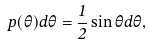Convert formula to latex. <formula><loc_0><loc_0><loc_500><loc_500>p ( \theta ) d \theta = \frac { 1 } { 2 } \sin \theta d \theta ,</formula> 